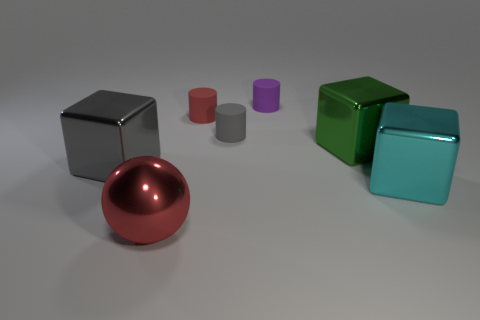What material is the big object that is to the left of the tiny gray cylinder and behind the cyan metal block?
Ensure brevity in your answer.  Metal. There is a small purple thing; what number of shiny balls are behind it?
Make the answer very short. 0. What number of green objects are there?
Offer a very short reply. 1. Is the size of the purple object the same as the red metallic ball?
Make the answer very short. No. Are there any red cylinders on the left side of the big thing behind the large metal cube to the left of the purple cylinder?
Give a very brief answer. Yes. There is a cyan object that is the same shape as the green shiny thing; what is its material?
Provide a short and direct response. Metal. The block that is to the left of the big red sphere is what color?
Provide a succinct answer. Gray. The cyan metallic object is what size?
Offer a very short reply. Large. There is a red metal object; does it have the same size as the cube left of the gray cylinder?
Make the answer very short. Yes. There is a big thing in front of the cyan thing right of the large green object that is to the right of the tiny red thing; what color is it?
Make the answer very short. Red. 